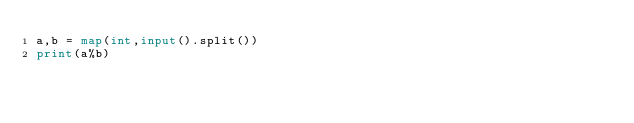<code> <loc_0><loc_0><loc_500><loc_500><_Python_>a,b = map(int,input().split())
print(a%b)</code> 